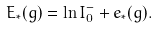Convert formula to latex. <formula><loc_0><loc_0><loc_500><loc_500>E _ { * } ( g ) = \ln I _ { 0 } ^ { - } + e _ { * } ( g ) .</formula> 